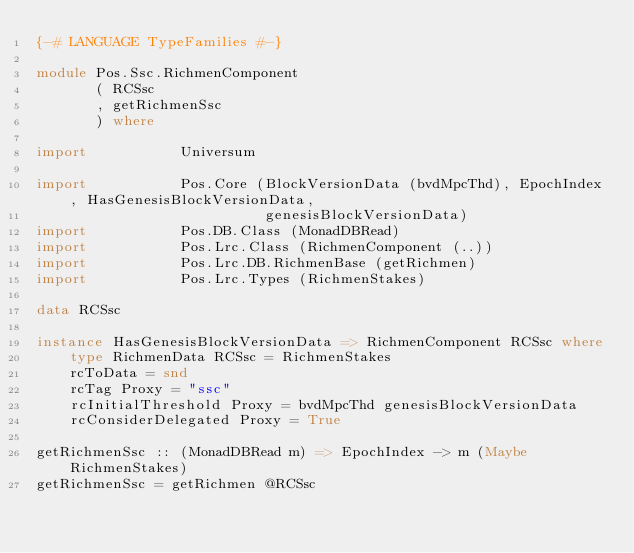Convert code to text. <code><loc_0><loc_0><loc_500><loc_500><_Haskell_>{-# LANGUAGE TypeFamilies #-}

module Pos.Ssc.RichmenComponent
       ( RCSsc
       , getRichmenSsc
       ) where

import           Universum

import           Pos.Core (BlockVersionData (bvdMpcThd), EpochIndex, HasGenesisBlockVersionData,
                           genesisBlockVersionData)
import           Pos.DB.Class (MonadDBRead)
import           Pos.Lrc.Class (RichmenComponent (..))
import           Pos.Lrc.DB.RichmenBase (getRichmen)
import           Pos.Lrc.Types (RichmenStakes)

data RCSsc

instance HasGenesisBlockVersionData => RichmenComponent RCSsc where
    type RichmenData RCSsc = RichmenStakes
    rcToData = snd
    rcTag Proxy = "ssc"
    rcInitialThreshold Proxy = bvdMpcThd genesisBlockVersionData
    rcConsiderDelegated Proxy = True

getRichmenSsc :: (MonadDBRead m) => EpochIndex -> m (Maybe RichmenStakes)
getRichmenSsc = getRichmen @RCSsc
</code> 